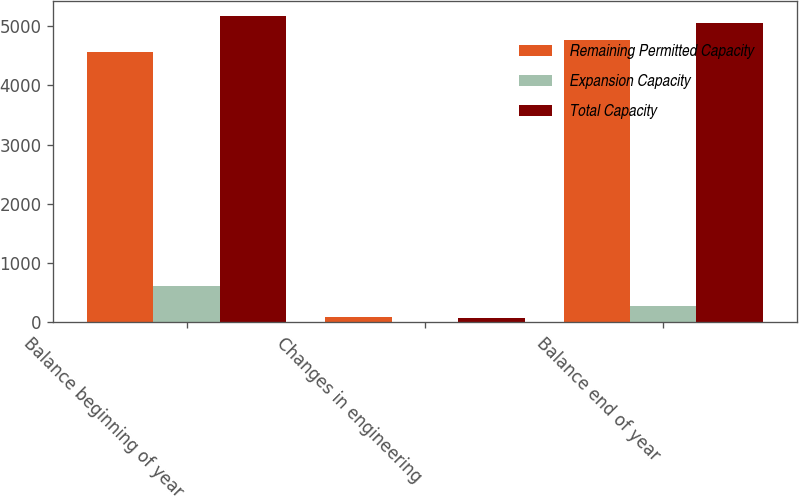Convert chart to OTSL. <chart><loc_0><loc_0><loc_500><loc_500><stacked_bar_chart><ecel><fcel>Balance beginning of year<fcel>Changes in engineering<fcel>Balance end of year<nl><fcel>Remaining Permitted Capacity<fcel>4558<fcel>82<fcel>4769<nl><fcel>Expansion Capacity<fcel>612<fcel>1<fcel>282<nl><fcel>Total Capacity<fcel>5170<fcel>81<fcel>5051<nl></chart> 